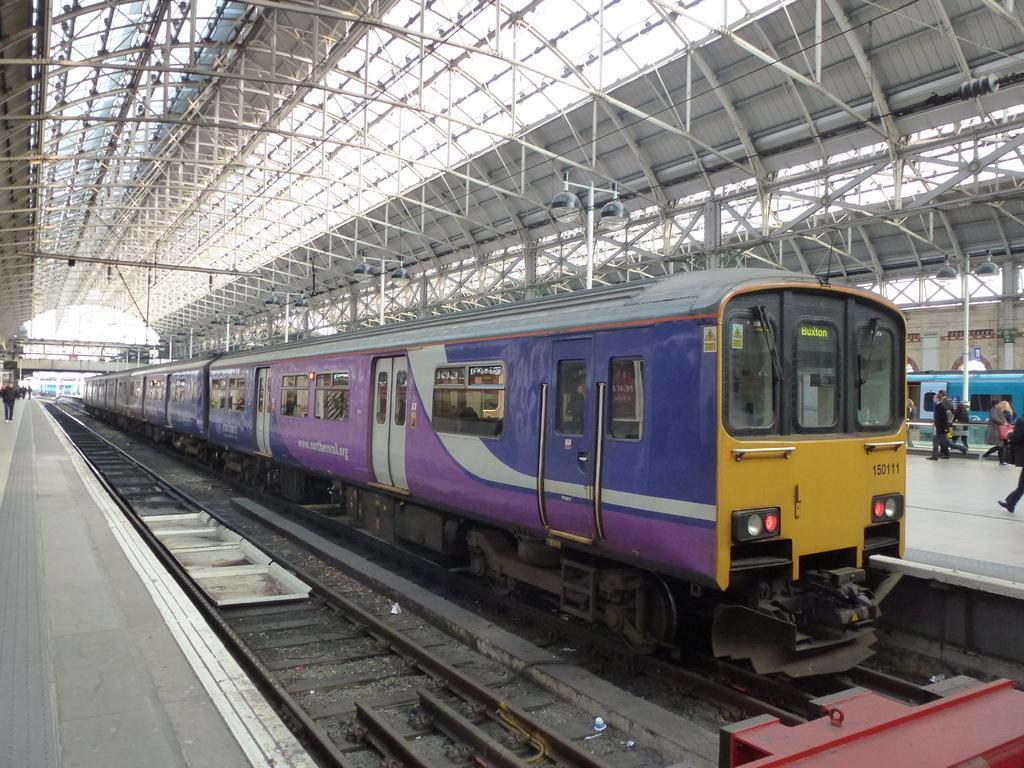In one or two sentences, can you explain what this image depicts? In this image, we can see a train is on the track. Here we can see another track. On left side and right side we can see platforms, few peoples. Here we can see a blue color train. In this image, we can see glass windows, doors, some stickers, windshield wipers. Top of the image, there is a shed roof with rods. Here we can see few poles with lights. 